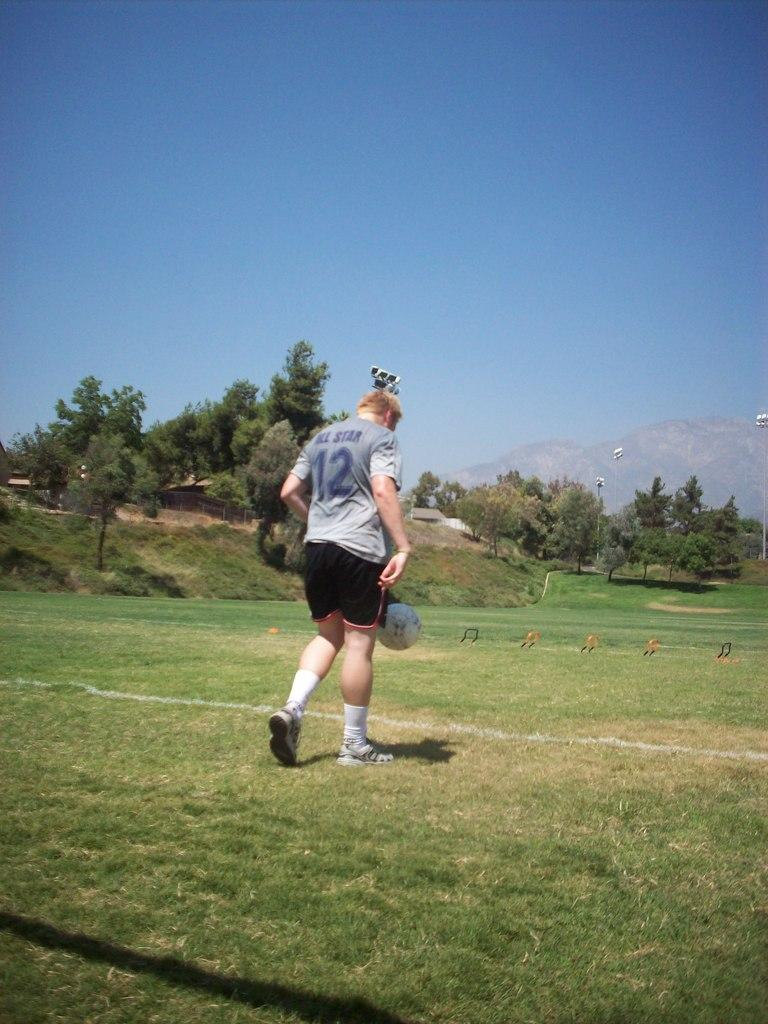<image>
Present a compact description of the photo's key features. A player wearing a number 12 jersey gets ready to kick a soccer ball away from his own goalpost. 